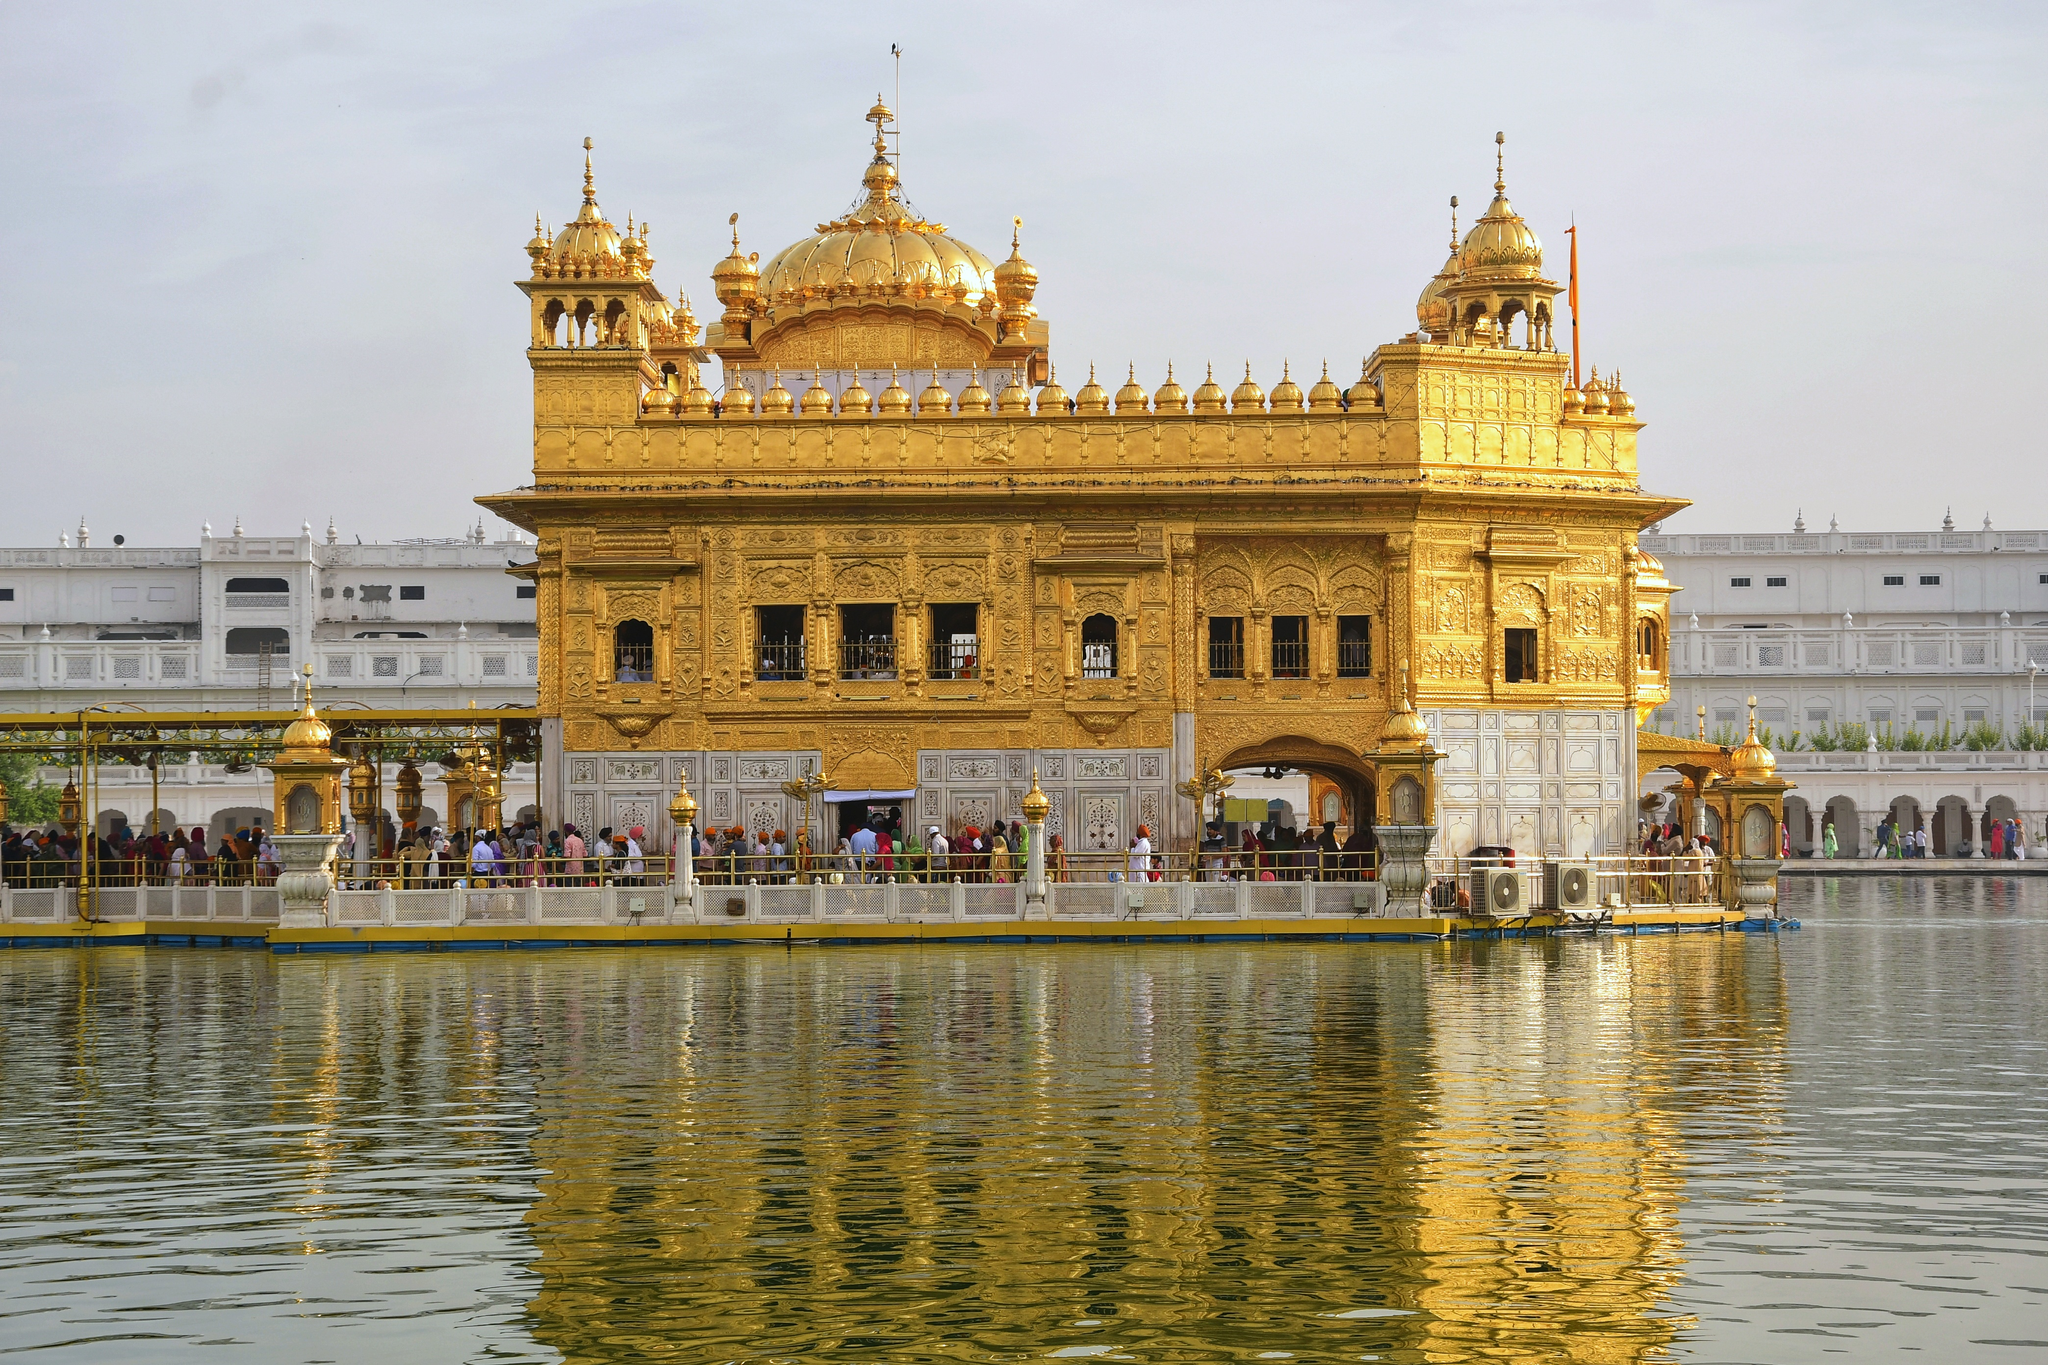What do you think is going on in this snapshot?
 The image captures the majestic Golden Temple, a renowned Sikh temple located in Amritsar, India. The temple's grandeur is accentuated by its golden exterior and multiple domes, which gleam against the overcast sky. The temple is nestled amidst a large pool of water, creating a mirror-like reflection that adds to the serene ambiance. A walkway encircles the pool, where people can be seen leisurely strolling, their figures adding a sense of scale to the imposing structure. The image is taken from a distance, offering a comprehensive view of the temple and its surroundings, predominantly bathed in hues of gold and white. The perspective provides a sense of the temple's significance, both in terms of its architectural magnificence and its cultural importance. 